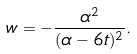<formula> <loc_0><loc_0><loc_500><loc_500>w = - \frac { \alpha ^ { 2 } } { ( \alpha - 6 t ) ^ { 2 } } .</formula> 